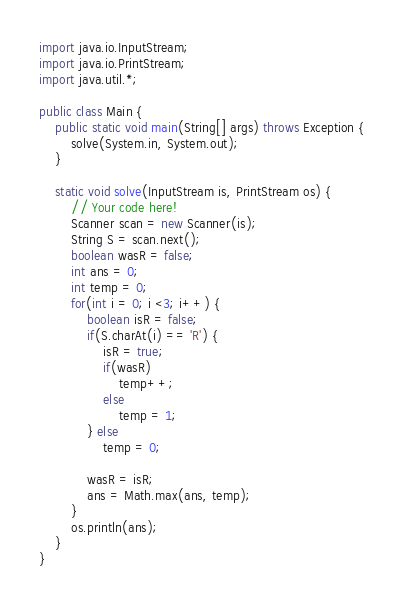Convert code to text. <code><loc_0><loc_0><loc_500><loc_500><_Java_>
import java.io.InputStream;
import java.io.PrintStream;
import java.util.*;

public class Main {
    public static void main(String[] args) throws Exception {
        solve(System.in, System.out);
    }

    static void solve(InputStream is, PrintStream os) {
        // Your code here!
        Scanner scan = new Scanner(is);
        String S = scan.next();
        boolean wasR = false;
        int ans = 0;
        int temp = 0;
        for(int i = 0; i <3; i++) {
            boolean isR = false;
            if(S.charAt(i) == 'R') {
                isR = true;
                if(wasR)
                    temp++;
                else
                    temp = 1;
            } else
                temp = 0;

            wasR = isR;
            ans = Math.max(ans, temp);
        }
        os.println(ans);
    }
}</code> 